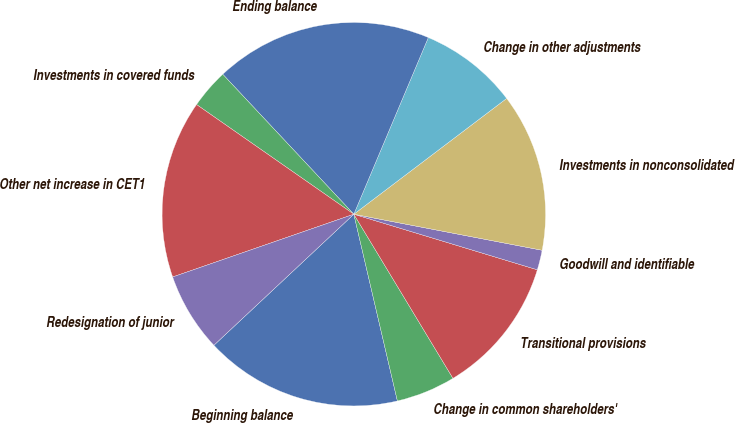Convert chart. <chart><loc_0><loc_0><loc_500><loc_500><pie_chart><fcel>Beginning balance<fcel>Change in common shareholders'<fcel>Transitional provisions<fcel>Goodwill and identifiable<fcel>Investments in nonconsolidated<fcel>Change in other adjustments<fcel>Ending balance<fcel>Investments in covered funds<fcel>Other net increase in CET1<fcel>Redesignation of junior<nl><fcel>16.67%<fcel>5.0%<fcel>11.67%<fcel>1.67%<fcel>13.33%<fcel>8.33%<fcel>18.33%<fcel>3.33%<fcel>15.0%<fcel>6.67%<nl></chart> 